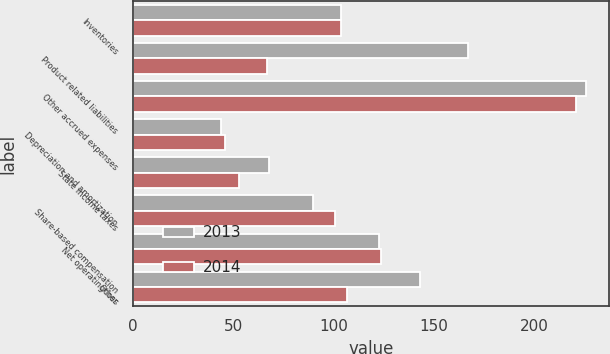Convert chart. <chart><loc_0><loc_0><loc_500><loc_500><stacked_bar_chart><ecel><fcel>Inventories<fcel>Product related liabilities<fcel>Other accrued expenses<fcel>Depreciation and amortization<fcel>State income taxes<fcel>Share-based compensation<fcel>Net operating loss<fcel>Other<nl><fcel>2013<fcel>104<fcel>167<fcel>226<fcel>44<fcel>68<fcel>90<fcel>123<fcel>143<nl><fcel>2014<fcel>104<fcel>67<fcel>221<fcel>46<fcel>53<fcel>101<fcel>124<fcel>107<nl></chart> 